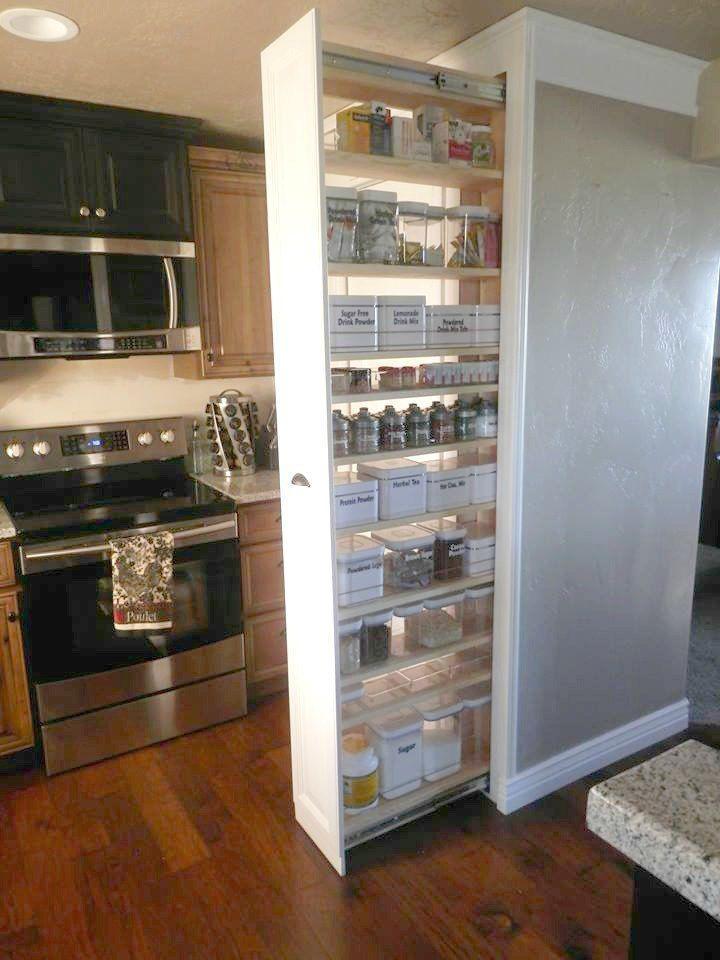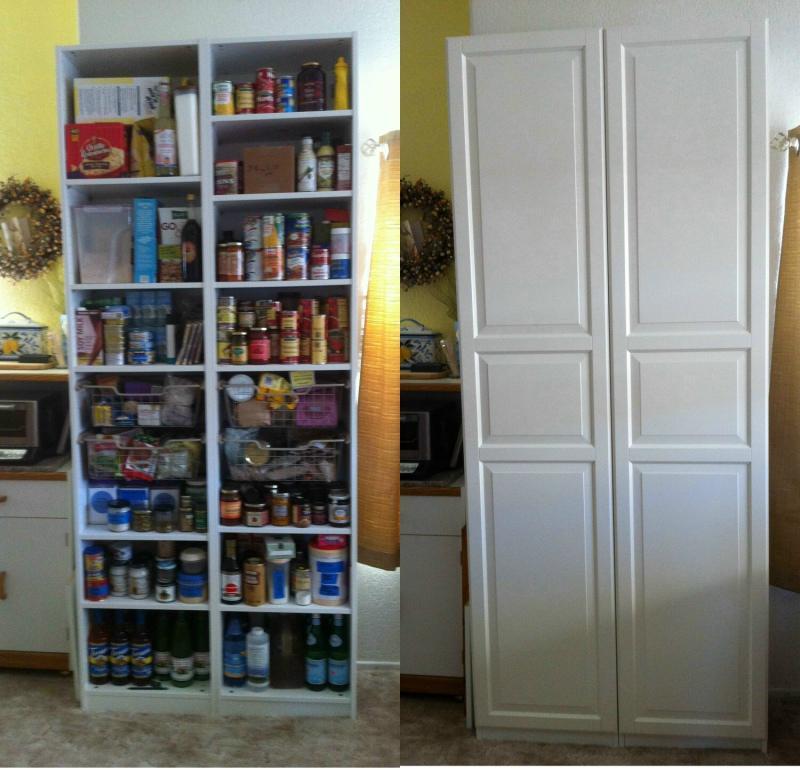The first image is the image on the left, the second image is the image on the right. For the images displayed, is the sentence "Left image shows a vertical storage pantry that pulls out, and the image does not include a refrigerator." factually correct? Answer yes or no. Yes. 